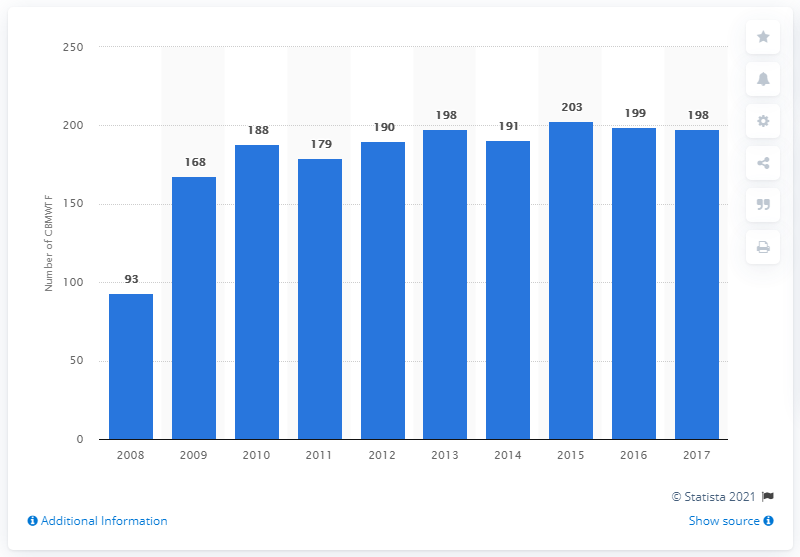Draw attention to some important aspects in this diagram. In 2017, a total of 198 biomedical waste treatment facilities were used in India. 